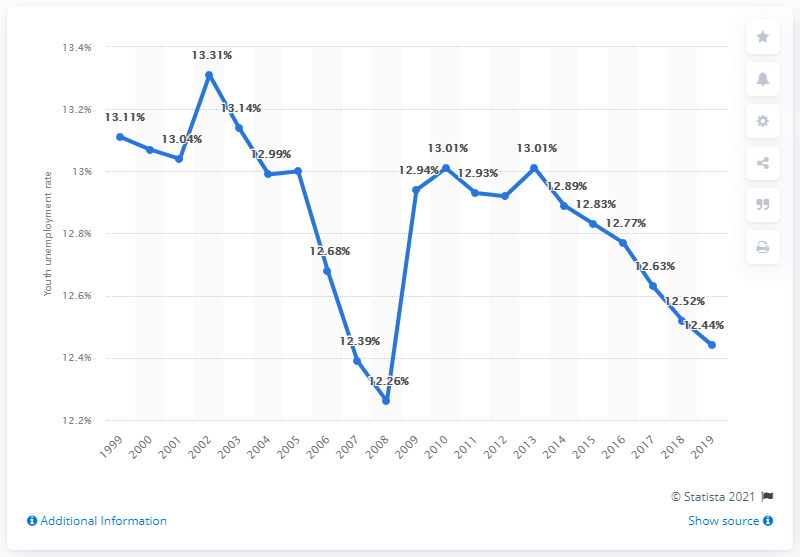Draw attention to some important aspects in this diagram. The youth unemployment rate in the Gambia in 2019 was 12.44%. 